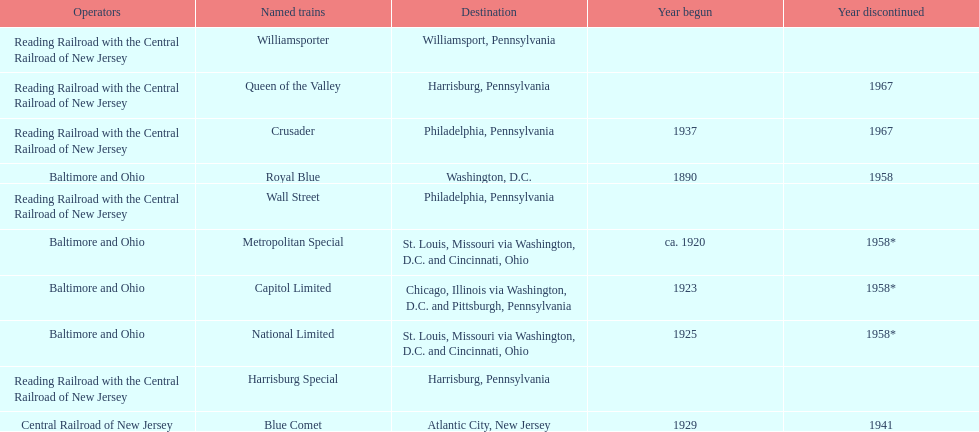What was the first train to begin service? Royal Blue. 